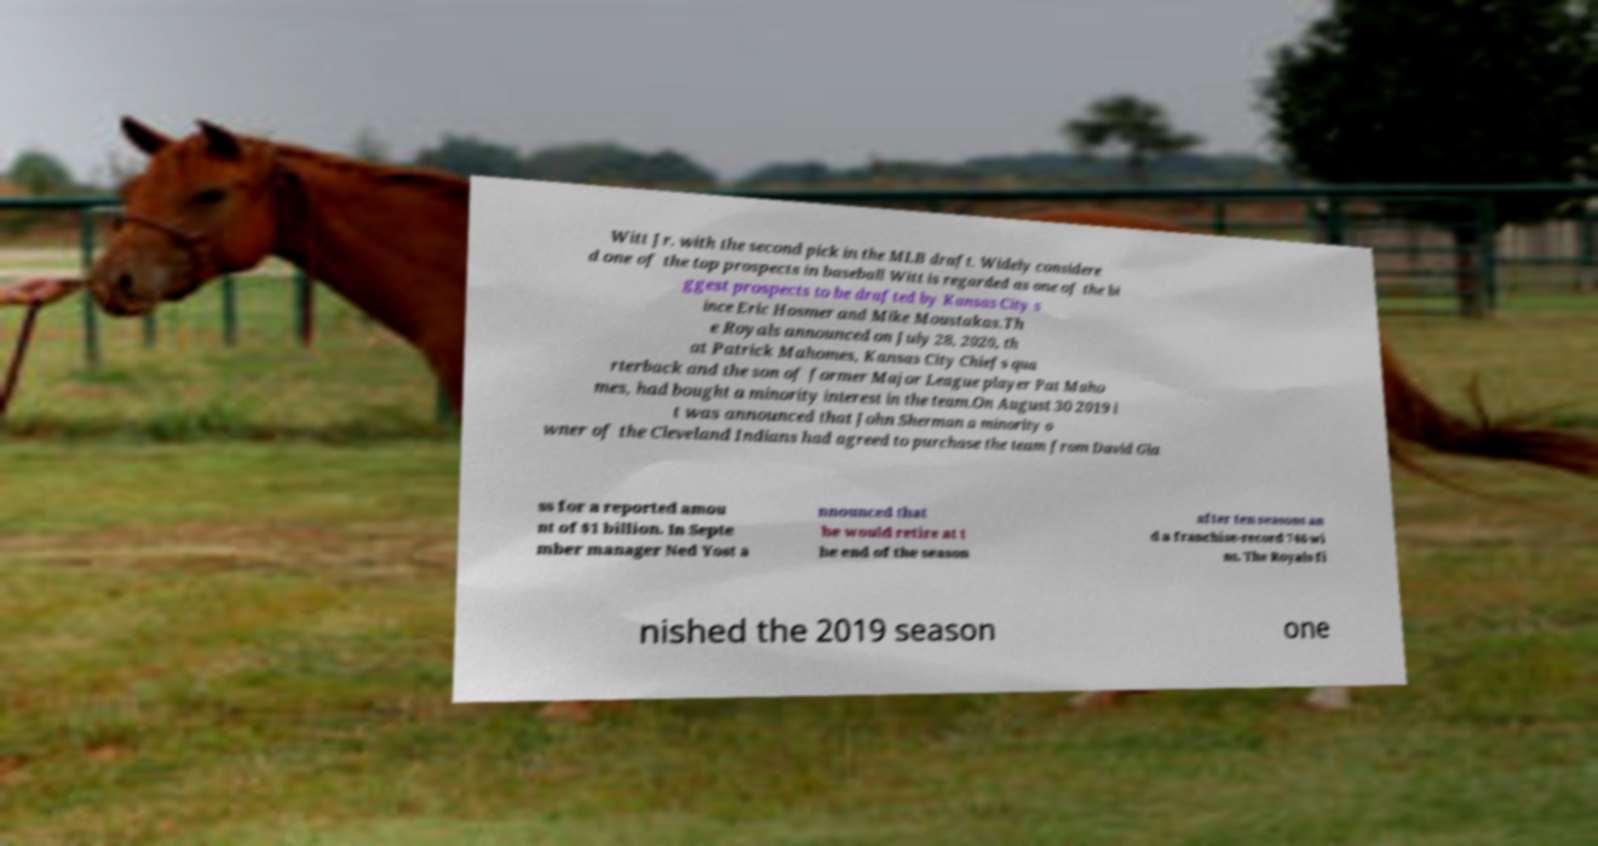Please read and relay the text visible in this image. What does it say? Witt Jr. with the second pick in the MLB draft. Widely considere d one of the top prospects in baseball Witt is regarded as one of the bi ggest prospects to be drafted by Kansas City s ince Eric Hosmer and Mike Moustakas.Th e Royals announced on July 28, 2020, th at Patrick Mahomes, Kansas City Chiefs qua rterback and the son of former Major League player Pat Maho mes, had bought a minority interest in the team.On August 30 2019 i t was announced that John Sherman a minority o wner of the Cleveland Indians had agreed to purchase the team from David Gla ss for a reported amou nt of $1 billion. In Septe mber manager Ned Yost a nnounced that he would retire at t he end of the season after ten seasons an d a franchise-record 746 wi ns. The Royals fi nished the 2019 season one 